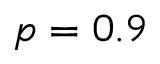Convert formula to latex. <formula><loc_0><loc_0><loc_500><loc_500>p = 0 . 9</formula> 